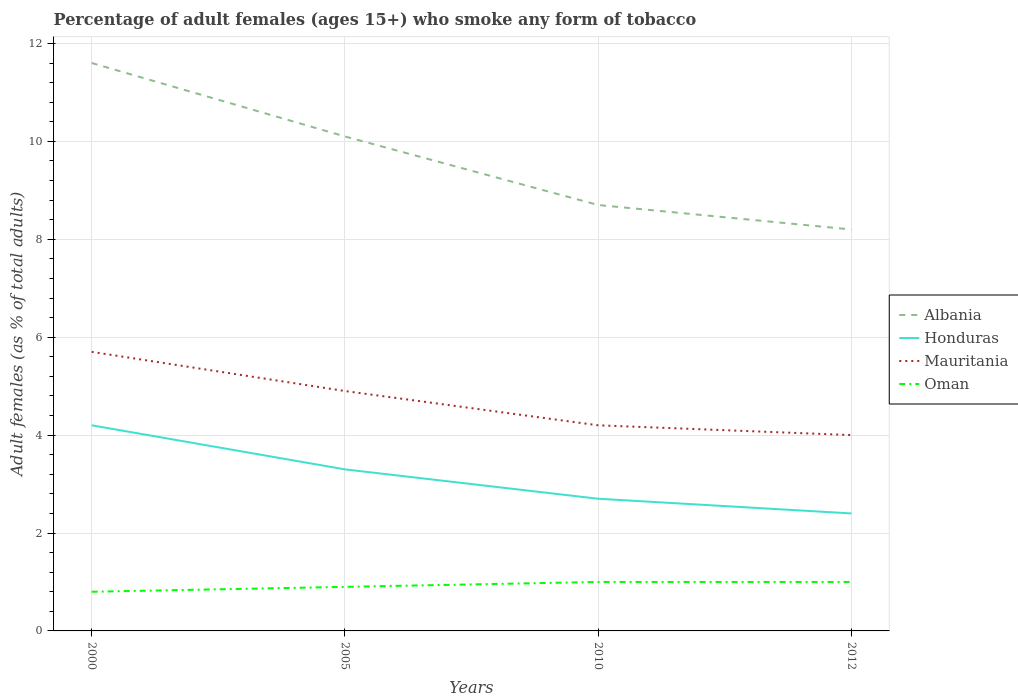How many different coloured lines are there?
Offer a very short reply. 4. In which year was the percentage of adult females who smoke in Albania maximum?
Ensure brevity in your answer.  2012. What is the total percentage of adult females who smoke in Honduras in the graph?
Provide a succinct answer. 0.9. What is the difference between the highest and the second highest percentage of adult females who smoke in Oman?
Ensure brevity in your answer.  0.2. What is the difference between the highest and the lowest percentage of adult females who smoke in Albania?
Offer a very short reply. 2. How many lines are there?
Provide a short and direct response. 4. How many years are there in the graph?
Offer a terse response. 4. What is the difference between two consecutive major ticks on the Y-axis?
Your answer should be very brief. 2. Are the values on the major ticks of Y-axis written in scientific E-notation?
Provide a succinct answer. No. How many legend labels are there?
Your response must be concise. 4. How are the legend labels stacked?
Provide a succinct answer. Vertical. What is the title of the graph?
Make the answer very short. Percentage of adult females (ages 15+) who smoke any form of tobacco. What is the label or title of the Y-axis?
Your response must be concise. Adult females (as % of total adults). What is the Adult females (as % of total adults) of Mauritania in 2000?
Make the answer very short. 5.7. What is the Adult females (as % of total adults) of Oman in 2000?
Offer a terse response. 0.8. What is the Adult females (as % of total adults) in Albania in 2005?
Keep it short and to the point. 10.1. What is the Adult females (as % of total adults) in Honduras in 2005?
Your answer should be very brief. 3.3. What is the Adult females (as % of total adults) in Albania in 2010?
Ensure brevity in your answer.  8.7. What is the Adult females (as % of total adults) of Honduras in 2010?
Your answer should be very brief. 2.7. What is the Adult females (as % of total adults) of Mauritania in 2010?
Make the answer very short. 4.2. What is the Adult females (as % of total adults) in Mauritania in 2012?
Make the answer very short. 4. What is the Adult females (as % of total adults) of Oman in 2012?
Your answer should be very brief. 1. Across all years, what is the maximum Adult females (as % of total adults) in Albania?
Provide a succinct answer. 11.6. Across all years, what is the maximum Adult females (as % of total adults) in Honduras?
Offer a very short reply. 4.2. Across all years, what is the maximum Adult females (as % of total adults) in Oman?
Offer a very short reply. 1. Across all years, what is the minimum Adult females (as % of total adults) of Albania?
Ensure brevity in your answer.  8.2. Across all years, what is the minimum Adult females (as % of total adults) in Honduras?
Your answer should be very brief. 2.4. What is the total Adult females (as % of total adults) of Albania in the graph?
Make the answer very short. 38.6. What is the total Adult females (as % of total adults) in Oman in the graph?
Keep it short and to the point. 3.7. What is the difference between the Adult females (as % of total adults) of Albania in 2000 and that in 2010?
Offer a terse response. 2.9. What is the difference between the Adult females (as % of total adults) in Honduras in 2000 and that in 2010?
Ensure brevity in your answer.  1.5. What is the difference between the Adult females (as % of total adults) in Mauritania in 2000 and that in 2012?
Provide a succinct answer. 1.7. What is the difference between the Adult females (as % of total adults) in Honduras in 2005 and that in 2010?
Offer a very short reply. 0.6. What is the difference between the Adult females (as % of total adults) in Oman in 2005 and that in 2010?
Provide a succinct answer. -0.1. What is the difference between the Adult females (as % of total adults) in Albania in 2005 and that in 2012?
Keep it short and to the point. 1.9. What is the difference between the Adult females (as % of total adults) of Honduras in 2005 and that in 2012?
Your response must be concise. 0.9. What is the difference between the Adult females (as % of total adults) in Mauritania in 2005 and that in 2012?
Make the answer very short. 0.9. What is the difference between the Adult females (as % of total adults) of Albania in 2010 and that in 2012?
Your answer should be compact. 0.5. What is the difference between the Adult females (as % of total adults) of Honduras in 2010 and that in 2012?
Offer a very short reply. 0.3. What is the difference between the Adult females (as % of total adults) of Mauritania in 2010 and that in 2012?
Your response must be concise. 0.2. What is the difference between the Adult females (as % of total adults) in Oman in 2010 and that in 2012?
Offer a terse response. 0. What is the difference between the Adult females (as % of total adults) in Albania in 2000 and the Adult females (as % of total adults) in Mauritania in 2005?
Your answer should be compact. 6.7. What is the difference between the Adult females (as % of total adults) in Albania in 2000 and the Adult females (as % of total adults) in Oman in 2005?
Give a very brief answer. 10.7. What is the difference between the Adult females (as % of total adults) of Honduras in 2000 and the Adult females (as % of total adults) of Mauritania in 2005?
Ensure brevity in your answer.  -0.7. What is the difference between the Adult females (as % of total adults) of Honduras in 2000 and the Adult females (as % of total adults) of Oman in 2005?
Provide a short and direct response. 3.3. What is the difference between the Adult females (as % of total adults) of Mauritania in 2000 and the Adult females (as % of total adults) of Oman in 2005?
Offer a very short reply. 4.8. What is the difference between the Adult females (as % of total adults) in Albania in 2000 and the Adult females (as % of total adults) in Honduras in 2010?
Provide a succinct answer. 8.9. What is the difference between the Adult females (as % of total adults) in Honduras in 2000 and the Adult females (as % of total adults) in Mauritania in 2010?
Give a very brief answer. 0. What is the difference between the Adult females (as % of total adults) of Honduras in 2000 and the Adult females (as % of total adults) of Oman in 2010?
Provide a short and direct response. 3.2. What is the difference between the Adult females (as % of total adults) of Mauritania in 2000 and the Adult females (as % of total adults) of Oman in 2010?
Ensure brevity in your answer.  4.7. What is the difference between the Adult females (as % of total adults) of Honduras in 2000 and the Adult females (as % of total adults) of Oman in 2012?
Provide a succinct answer. 3.2. What is the difference between the Adult females (as % of total adults) in Mauritania in 2000 and the Adult females (as % of total adults) in Oman in 2012?
Make the answer very short. 4.7. What is the difference between the Adult females (as % of total adults) in Albania in 2005 and the Adult females (as % of total adults) in Honduras in 2010?
Offer a terse response. 7.4. What is the difference between the Adult females (as % of total adults) in Albania in 2005 and the Adult females (as % of total adults) in Oman in 2010?
Your answer should be compact. 9.1. What is the difference between the Adult females (as % of total adults) in Honduras in 2005 and the Adult females (as % of total adults) in Oman in 2010?
Your response must be concise. 2.3. What is the difference between the Adult females (as % of total adults) in Mauritania in 2005 and the Adult females (as % of total adults) in Oman in 2010?
Offer a very short reply. 3.9. What is the difference between the Adult females (as % of total adults) of Albania in 2005 and the Adult females (as % of total adults) of Mauritania in 2012?
Provide a short and direct response. 6.1. What is the difference between the Adult females (as % of total adults) of Albania in 2005 and the Adult females (as % of total adults) of Oman in 2012?
Your answer should be very brief. 9.1. What is the difference between the Adult females (as % of total adults) of Honduras in 2005 and the Adult females (as % of total adults) of Mauritania in 2012?
Give a very brief answer. -0.7. What is the difference between the Adult females (as % of total adults) in Honduras in 2005 and the Adult females (as % of total adults) in Oman in 2012?
Provide a succinct answer. 2.3. What is the difference between the Adult females (as % of total adults) in Mauritania in 2005 and the Adult females (as % of total adults) in Oman in 2012?
Make the answer very short. 3.9. What is the difference between the Adult females (as % of total adults) in Honduras in 2010 and the Adult females (as % of total adults) in Mauritania in 2012?
Give a very brief answer. -1.3. What is the difference between the Adult females (as % of total adults) in Honduras in 2010 and the Adult females (as % of total adults) in Oman in 2012?
Your answer should be very brief. 1.7. What is the average Adult females (as % of total adults) in Albania per year?
Offer a terse response. 9.65. What is the average Adult females (as % of total adults) in Honduras per year?
Your answer should be compact. 3.15. What is the average Adult females (as % of total adults) of Oman per year?
Make the answer very short. 0.93. In the year 2000, what is the difference between the Adult females (as % of total adults) in Albania and Adult females (as % of total adults) in Oman?
Offer a terse response. 10.8. In the year 2000, what is the difference between the Adult females (as % of total adults) in Honduras and Adult females (as % of total adults) in Oman?
Offer a terse response. 3.4. In the year 2000, what is the difference between the Adult females (as % of total adults) in Mauritania and Adult females (as % of total adults) in Oman?
Your answer should be very brief. 4.9. In the year 2005, what is the difference between the Adult females (as % of total adults) of Albania and Adult females (as % of total adults) of Mauritania?
Your answer should be compact. 5.2. In the year 2005, what is the difference between the Adult females (as % of total adults) of Honduras and Adult females (as % of total adults) of Oman?
Keep it short and to the point. 2.4. In the year 2005, what is the difference between the Adult females (as % of total adults) in Mauritania and Adult females (as % of total adults) in Oman?
Offer a very short reply. 4. In the year 2010, what is the difference between the Adult females (as % of total adults) of Albania and Adult females (as % of total adults) of Honduras?
Give a very brief answer. 6. In the year 2010, what is the difference between the Adult females (as % of total adults) in Mauritania and Adult females (as % of total adults) in Oman?
Your answer should be very brief. 3.2. In the year 2012, what is the difference between the Adult females (as % of total adults) of Albania and Adult females (as % of total adults) of Honduras?
Your response must be concise. 5.8. In the year 2012, what is the difference between the Adult females (as % of total adults) of Albania and Adult females (as % of total adults) of Mauritania?
Offer a very short reply. 4.2. In the year 2012, what is the difference between the Adult females (as % of total adults) of Albania and Adult females (as % of total adults) of Oman?
Provide a short and direct response. 7.2. What is the ratio of the Adult females (as % of total adults) in Albania in 2000 to that in 2005?
Your answer should be compact. 1.15. What is the ratio of the Adult females (as % of total adults) in Honduras in 2000 to that in 2005?
Ensure brevity in your answer.  1.27. What is the ratio of the Adult females (as % of total adults) in Mauritania in 2000 to that in 2005?
Provide a short and direct response. 1.16. What is the ratio of the Adult females (as % of total adults) in Oman in 2000 to that in 2005?
Ensure brevity in your answer.  0.89. What is the ratio of the Adult females (as % of total adults) in Honduras in 2000 to that in 2010?
Offer a very short reply. 1.56. What is the ratio of the Adult females (as % of total adults) of Mauritania in 2000 to that in 2010?
Your answer should be very brief. 1.36. What is the ratio of the Adult females (as % of total adults) of Oman in 2000 to that in 2010?
Ensure brevity in your answer.  0.8. What is the ratio of the Adult females (as % of total adults) in Albania in 2000 to that in 2012?
Give a very brief answer. 1.41. What is the ratio of the Adult females (as % of total adults) in Mauritania in 2000 to that in 2012?
Your response must be concise. 1.43. What is the ratio of the Adult females (as % of total adults) of Oman in 2000 to that in 2012?
Offer a very short reply. 0.8. What is the ratio of the Adult females (as % of total adults) of Albania in 2005 to that in 2010?
Keep it short and to the point. 1.16. What is the ratio of the Adult females (as % of total adults) in Honduras in 2005 to that in 2010?
Provide a succinct answer. 1.22. What is the ratio of the Adult females (as % of total adults) in Oman in 2005 to that in 2010?
Ensure brevity in your answer.  0.9. What is the ratio of the Adult females (as % of total adults) of Albania in 2005 to that in 2012?
Offer a terse response. 1.23. What is the ratio of the Adult females (as % of total adults) of Honduras in 2005 to that in 2012?
Make the answer very short. 1.38. What is the ratio of the Adult females (as % of total adults) in Mauritania in 2005 to that in 2012?
Provide a short and direct response. 1.23. What is the ratio of the Adult females (as % of total adults) of Albania in 2010 to that in 2012?
Make the answer very short. 1.06. What is the ratio of the Adult females (as % of total adults) of Mauritania in 2010 to that in 2012?
Keep it short and to the point. 1.05. What is the ratio of the Adult females (as % of total adults) in Oman in 2010 to that in 2012?
Provide a short and direct response. 1. What is the difference between the highest and the second highest Adult females (as % of total adults) in Honduras?
Offer a terse response. 0.9. What is the difference between the highest and the second highest Adult females (as % of total adults) in Oman?
Make the answer very short. 0. What is the difference between the highest and the lowest Adult females (as % of total adults) of Albania?
Ensure brevity in your answer.  3.4. What is the difference between the highest and the lowest Adult females (as % of total adults) of Mauritania?
Keep it short and to the point. 1.7. 